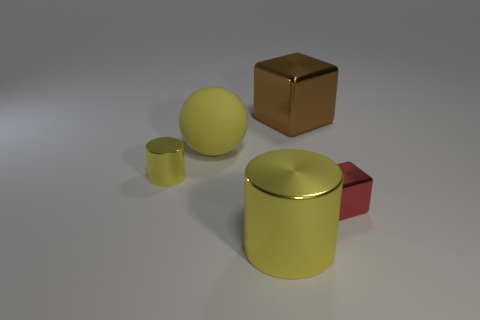What number of gray things have the same shape as the tiny yellow metallic thing?
Your response must be concise. 0. What number of brown things are either small spheres or big metallic blocks?
Your response must be concise. 1. How big is the yellow metallic thing on the left side of the yellow object to the right of the big rubber object?
Your answer should be very brief. Small. What is the material of the tiny red thing that is the same shape as the big brown object?
Your response must be concise. Metal. How many green cylinders are the same size as the yellow rubber thing?
Provide a succinct answer. 0. Is the size of the brown shiny block the same as the sphere?
Make the answer very short. Yes. What size is the object that is both behind the tiny red shiny cube and to the right of the matte sphere?
Provide a short and direct response. Large. Is the number of tiny shiny things to the left of the red cube greater than the number of big yellow metal things that are behind the big matte object?
Make the answer very short. Yes. There is another small thing that is the same shape as the brown object; what is its color?
Provide a short and direct response. Red. Do the block in front of the brown cube and the big matte object have the same color?
Your answer should be compact. No. 